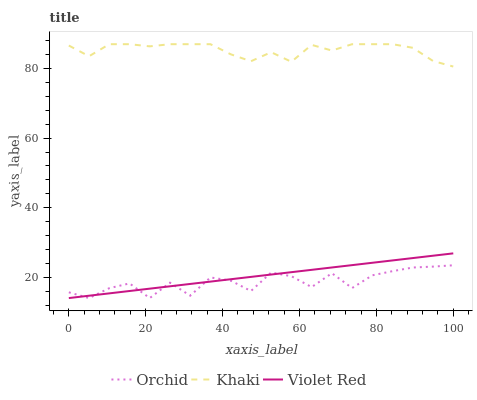Does Orchid have the minimum area under the curve?
Answer yes or no. Yes. Does Khaki have the maximum area under the curve?
Answer yes or no. Yes. Does Khaki have the minimum area under the curve?
Answer yes or no. No. Does Orchid have the maximum area under the curve?
Answer yes or no. No. Is Violet Red the smoothest?
Answer yes or no. Yes. Is Orchid the roughest?
Answer yes or no. Yes. Is Khaki the smoothest?
Answer yes or no. No. Is Khaki the roughest?
Answer yes or no. No. Does Violet Red have the lowest value?
Answer yes or no. Yes. Does Khaki have the lowest value?
Answer yes or no. No. Does Khaki have the highest value?
Answer yes or no. Yes. Does Orchid have the highest value?
Answer yes or no. No. Is Orchid less than Khaki?
Answer yes or no. Yes. Is Khaki greater than Orchid?
Answer yes or no. Yes. Does Violet Red intersect Orchid?
Answer yes or no. Yes. Is Violet Red less than Orchid?
Answer yes or no. No. Is Violet Red greater than Orchid?
Answer yes or no. No. Does Orchid intersect Khaki?
Answer yes or no. No. 